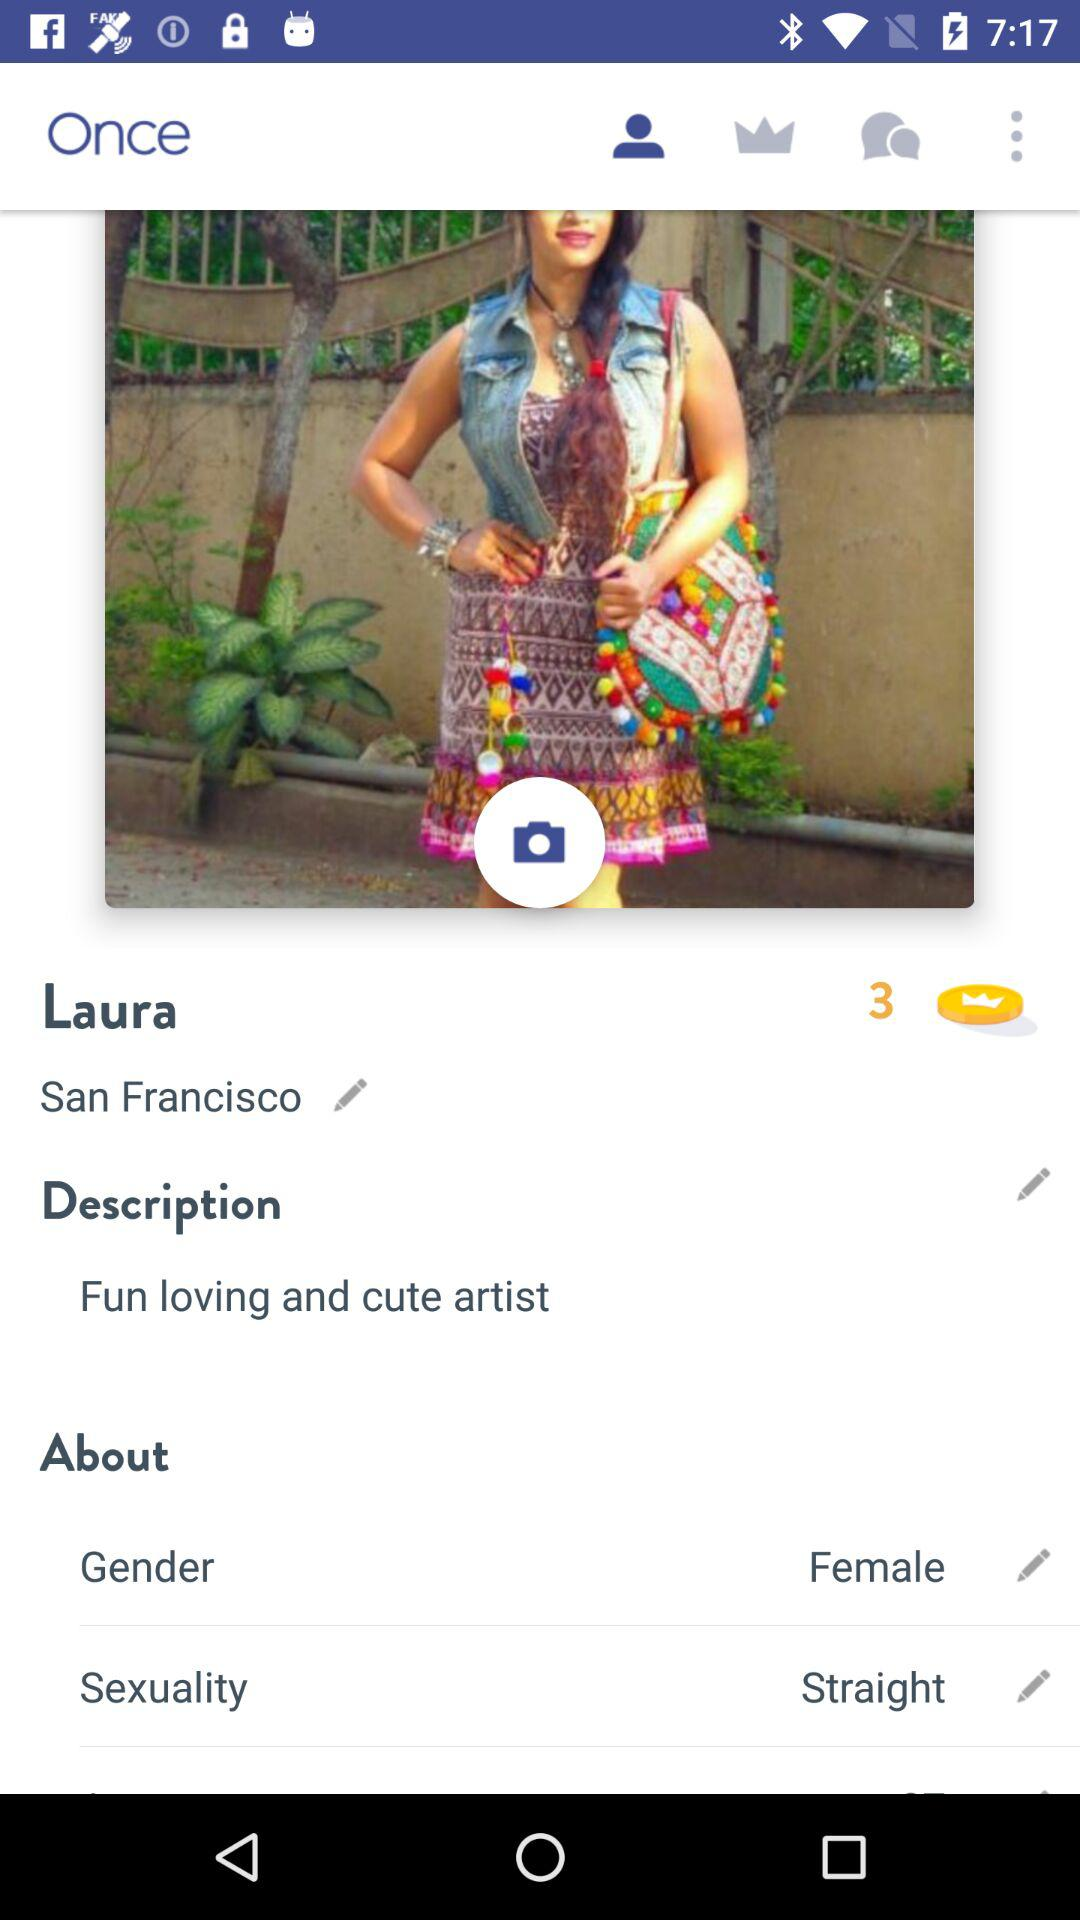What is the mentioned location? The mentioned location is San Francisco. 